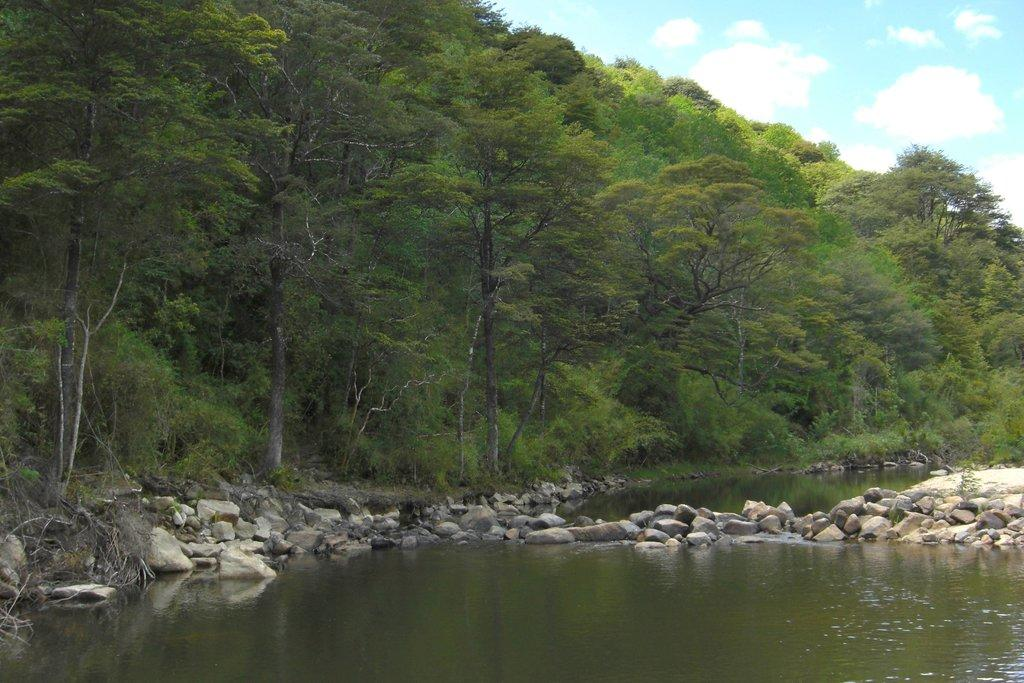What is present at the bottom of the image? There is water at the bottom of the image. What objects can be seen in the middle of the image? There are stones in the middle of the image. What type of vegetation is visible in the image? There are trees in the image. What is visible at the top of the image? The sky is visible at the top of the image. Where is the hen located in the image? There is no hen present in the image. What is the purpose of the drain in the image? There is no drain present in the image. 